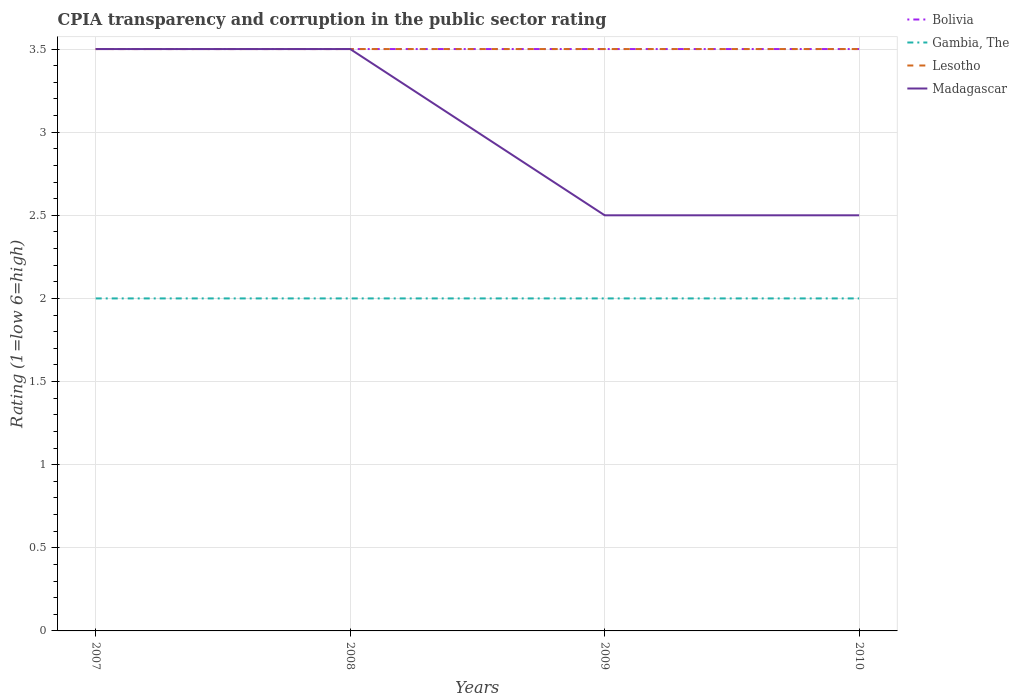How many different coloured lines are there?
Give a very brief answer. 4. Does the line corresponding to Lesotho intersect with the line corresponding to Bolivia?
Offer a terse response. Yes. Is the number of lines equal to the number of legend labels?
Ensure brevity in your answer.  Yes. Across all years, what is the maximum CPIA rating in Madagascar?
Your answer should be very brief. 2.5. What is the total CPIA rating in Lesotho in the graph?
Offer a very short reply. 0. What is the difference between the highest and the second highest CPIA rating in Madagascar?
Make the answer very short. 1. What is the difference between two consecutive major ticks on the Y-axis?
Provide a succinct answer. 0.5. How many legend labels are there?
Your answer should be very brief. 4. How are the legend labels stacked?
Ensure brevity in your answer.  Vertical. What is the title of the graph?
Provide a short and direct response. CPIA transparency and corruption in the public sector rating. What is the label or title of the X-axis?
Your response must be concise. Years. What is the label or title of the Y-axis?
Offer a very short reply. Rating (1=low 6=high). What is the Rating (1=low 6=high) of Bolivia in 2007?
Give a very brief answer. 3.5. What is the Rating (1=low 6=high) in Lesotho in 2007?
Your answer should be compact. 3.5. What is the Rating (1=low 6=high) of Madagascar in 2007?
Provide a short and direct response. 3.5. What is the Rating (1=low 6=high) in Gambia, The in 2008?
Offer a very short reply. 2. What is the Rating (1=low 6=high) in Lesotho in 2008?
Provide a short and direct response. 3.5. What is the Rating (1=low 6=high) of Gambia, The in 2010?
Ensure brevity in your answer.  2. What is the Rating (1=low 6=high) in Lesotho in 2010?
Keep it short and to the point. 3.5. Across all years, what is the minimum Rating (1=low 6=high) in Bolivia?
Your answer should be compact. 3.5. Across all years, what is the minimum Rating (1=low 6=high) of Gambia, The?
Offer a very short reply. 2. What is the total Rating (1=low 6=high) of Gambia, The in the graph?
Your answer should be very brief. 8. What is the total Rating (1=low 6=high) in Madagascar in the graph?
Your answer should be very brief. 12. What is the difference between the Rating (1=low 6=high) of Bolivia in 2007 and that in 2008?
Your response must be concise. 0. What is the difference between the Rating (1=low 6=high) in Gambia, The in 2007 and that in 2010?
Offer a very short reply. 0. What is the difference between the Rating (1=low 6=high) in Madagascar in 2008 and that in 2009?
Give a very brief answer. 1. What is the difference between the Rating (1=low 6=high) in Bolivia in 2008 and that in 2010?
Your answer should be very brief. 0. What is the difference between the Rating (1=low 6=high) in Gambia, The in 2008 and that in 2010?
Keep it short and to the point. 0. What is the difference between the Rating (1=low 6=high) of Lesotho in 2008 and that in 2010?
Your answer should be very brief. 0. What is the difference between the Rating (1=low 6=high) in Lesotho in 2009 and that in 2010?
Make the answer very short. 0. What is the difference between the Rating (1=low 6=high) in Bolivia in 2007 and the Rating (1=low 6=high) in Lesotho in 2008?
Give a very brief answer. 0. What is the difference between the Rating (1=low 6=high) of Gambia, The in 2007 and the Rating (1=low 6=high) of Lesotho in 2008?
Make the answer very short. -1.5. What is the difference between the Rating (1=low 6=high) in Gambia, The in 2007 and the Rating (1=low 6=high) in Madagascar in 2008?
Make the answer very short. -1.5. What is the difference between the Rating (1=low 6=high) of Bolivia in 2007 and the Rating (1=low 6=high) of Gambia, The in 2009?
Your answer should be very brief. 1.5. What is the difference between the Rating (1=low 6=high) of Bolivia in 2007 and the Rating (1=low 6=high) of Lesotho in 2009?
Offer a very short reply. 0. What is the difference between the Rating (1=low 6=high) of Bolivia in 2007 and the Rating (1=low 6=high) of Madagascar in 2009?
Make the answer very short. 1. What is the difference between the Rating (1=low 6=high) of Gambia, The in 2007 and the Rating (1=low 6=high) of Madagascar in 2009?
Offer a very short reply. -0.5. What is the difference between the Rating (1=low 6=high) in Bolivia in 2007 and the Rating (1=low 6=high) in Gambia, The in 2010?
Your response must be concise. 1.5. What is the difference between the Rating (1=low 6=high) in Bolivia in 2007 and the Rating (1=low 6=high) in Lesotho in 2010?
Make the answer very short. 0. What is the difference between the Rating (1=low 6=high) in Gambia, The in 2008 and the Rating (1=low 6=high) in Lesotho in 2009?
Your answer should be compact. -1.5. What is the difference between the Rating (1=low 6=high) of Bolivia in 2008 and the Rating (1=low 6=high) of Gambia, The in 2010?
Offer a terse response. 1.5. What is the difference between the Rating (1=low 6=high) in Bolivia in 2008 and the Rating (1=low 6=high) in Lesotho in 2010?
Provide a succinct answer. 0. What is the difference between the Rating (1=low 6=high) of Gambia, The in 2008 and the Rating (1=low 6=high) of Lesotho in 2010?
Your response must be concise. -1.5. What is the difference between the Rating (1=low 6=high) of Gambia, The in 2008 and the Rating (1=low 6=high) of Madagascar in 2010?
Ensure brevity in your answer.  -0.5. What is the difference between the Rating (1=low 6=high) in Lesotho in 2008 and the Rating (1=low 6=high) in Madagascar in 2010?
Offer a terse response. 1. What is the difference between the Rating (1=low 6=high) of Bolivia in 2009 and the Rating (1=low 6=high) of Lesotho in 2010?
Your answer should be very brief. 0. What is the difference between the Rating (1=low 6=high) in Bolivia in 2009 and the Rating (1=low 6=high) in Madagascar in 2010?
Offer a very short reply. 1. What is the difference between the Rating (1=low 6=high) of Lesotho in 2009 and the Rating (1=low 6=high) of Madagascar in 2010?
Your answer should be very brief. 1. What is the average Rating (1=low 6=high) in Bolivia per year?
Offer a terse response. 3.5. What is the average Rating (1=low 6=high) in Madagascar per year?
Your response must be concise. 3. In the year 2007, what is the difference between the Rating (1=low 6=high) of Bolivia and Rating (1=low 6=high) of Gambia, The?
Provide a short and direct response. 1.5. In the year 2007, what is the difference between the Rating (1=low 6=high) of Bolivia and Rating (1=low 6=high) of Lesotho?
Your answer should be very brief. 0. In the year 2007, what is the difference between the Rating (1=low 6=high) of Bolivia and Rating (1=low 6=high) of Madagascar?
Provide a short and direct response. 0. In the year 2007, what is the difference between the Rating (1=low 6=high) in Gambia, The and Rating (1=low 6=high) in Lesotho?
Keep it short and to the point. -1.5. In the year 2007, what is the difference between the Rating (1=low 6=high) in Gambia, The and Rating (1=low 6=high) in Madagascar?
Ensure brevity in your answer.  -1.5. In the year 2009, what is the difference between the Rating (1=low 6=high) in Bolivia and Rating (1=low 6=high) in Gambia, The?
Ensure brevity in your answer.  1.5. In the year 2009, what is the difference between the Rating (1=low 6=high) of Bolivia and Rating (1=low 6=high) of Lesotho?
Offer a terse response. 0. In the year 2009, what is the difference between the Rating (1=low 6=high) of Gambia, The and Rating (1=low 6=high) of Lesotho?
Make the answer very short. -1.5. In the year 2010, what is the difference between the Rating (1=low 6=high) in Bolivia and Rating (1=low 6=high) in Lesotho?
Give a very brief answer. 0. In the year 2010, what is the difference between the Rating (1=low 6=high) in Bolivia and Rating (1=low 6=high) in Madagascar?
Your response must be concise. 1. What is the ratio of the Rating (1=low 6=high) in Bolivia in 2007 to that in 2008?
Offer a very short reply. 1. What is the ratio of the Rating (1=low 6=high) of Lesotho in 2007 to that in 2008?
Provide a short and direct response. 1. What is the ratio of the Rating (1=low 6=high) in Madagascar in 2007 to that in 2008?
Offer a terse response. 1. What is the ratio of the Rating (1=low 6=high) of Gambia, The in 2007 to that in 2010?
Make the answer very short. 1. What is the ratio of the Rating (1=low 6=high) in Lesotho in 2007 to that in 2010?
Ensure brevity in your answer.  1. What is the ratio of the Rating (1=low 6=high) in Gambia, The in 2008 to that in 2009?
Offer a terse response. 1. What is the ratio of the Rating (1=low 6=high) in Bolivia in 2008 to that in 2010?
Your answer should be very brief. 1. What is the ratio of the Rating (1=low 6=high) in Lesotho in 2008 to that in 2010?
Your answer should be very brief. 1. What is the ratio of the Rating (1=low 6=high) in Madagascar in 2009 to that in 2010?
Keep it short and to the point. 1. What is the difference between the highest and the second highest Rating (1=low 6=high) in Gambia, The?
Give a very brief answer. 0. What is the difference between the highest and the lowest Rating (1=low 6=high) of Lesotho?
Give a very brief answer. 0. 